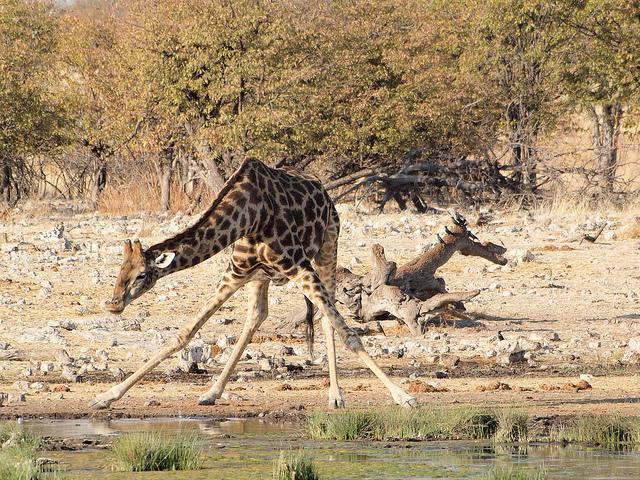What is in the picture?
Write a very short answer. Giraffe. Why does the giraffe stand that way?
Be succinct. To drink water. Is the giraffe going to run?
Be succinct. No. What does this giraffe have in common with cheerleaders?
Short answer required. Splits. 